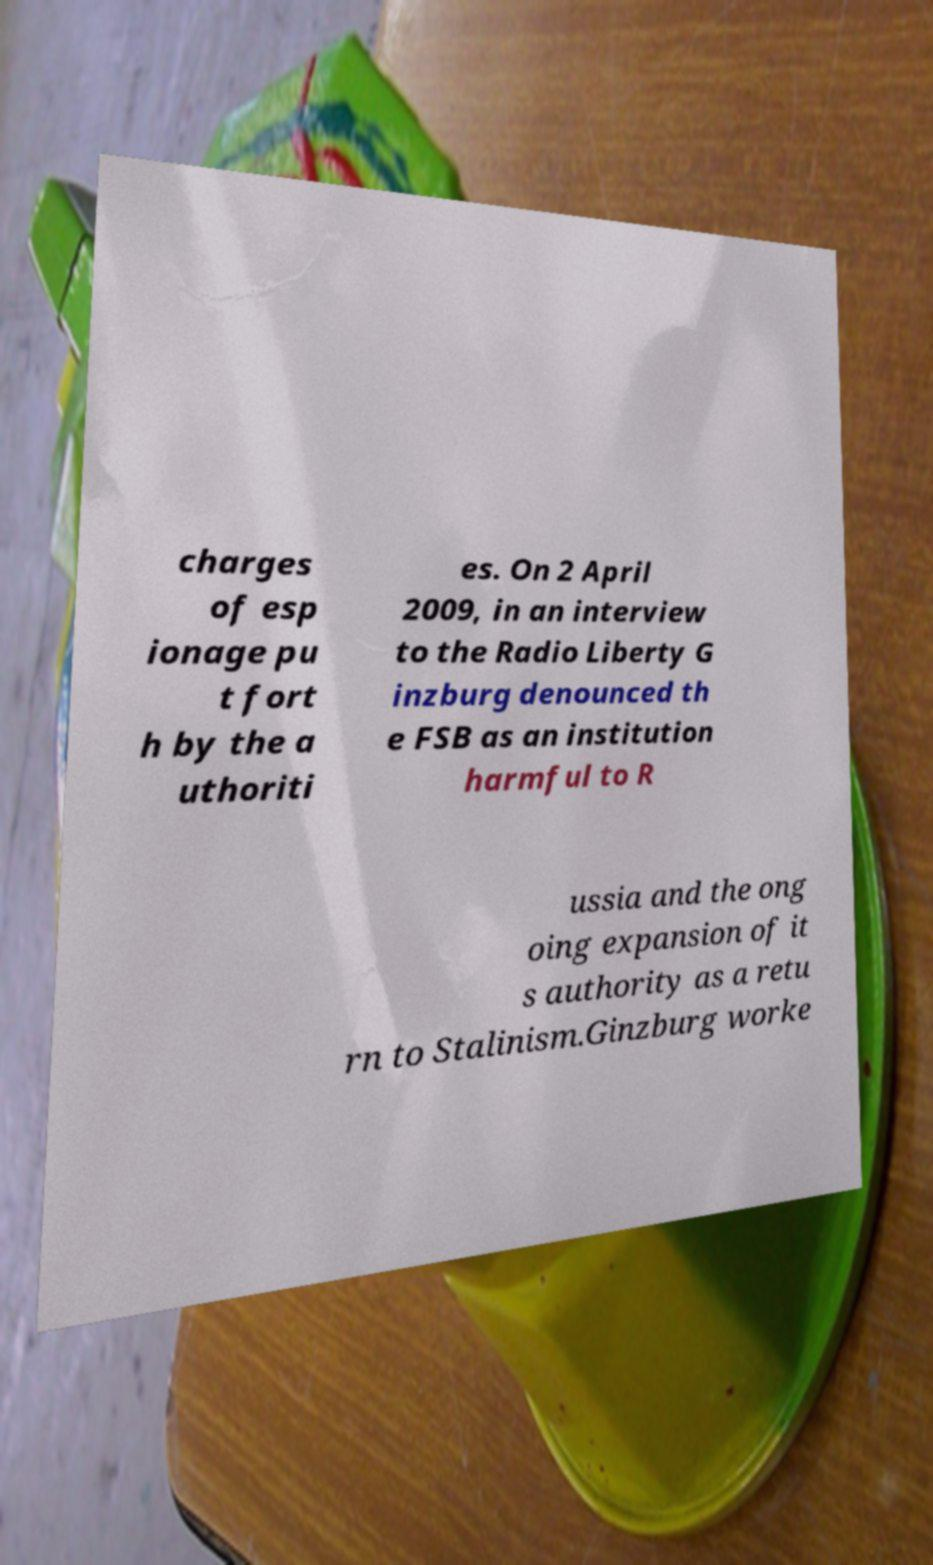What messages or text are displayed in this image? I need them in a readable, typed format. charges of esp ionage pu t fort h by the a uthoriti es. On 2 April 2009, in an interview to the Radio Liberty G inzburg denounced th e FSB as an institution harmful to R ussia and the ong oing expansion of it s authority as a retu rn to Stalinism.Ginzburg worke 